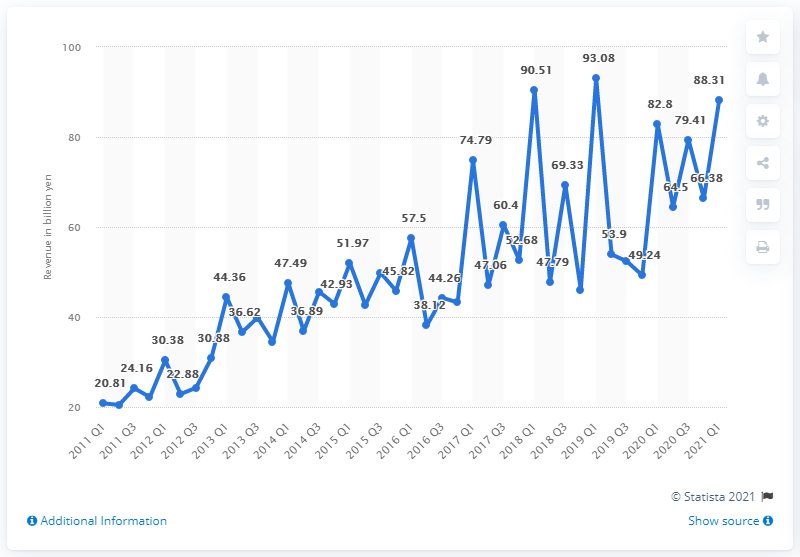Point out several critical features in this image. In the first quarter of 2021, Nexon's revenue was 88.31 million. 